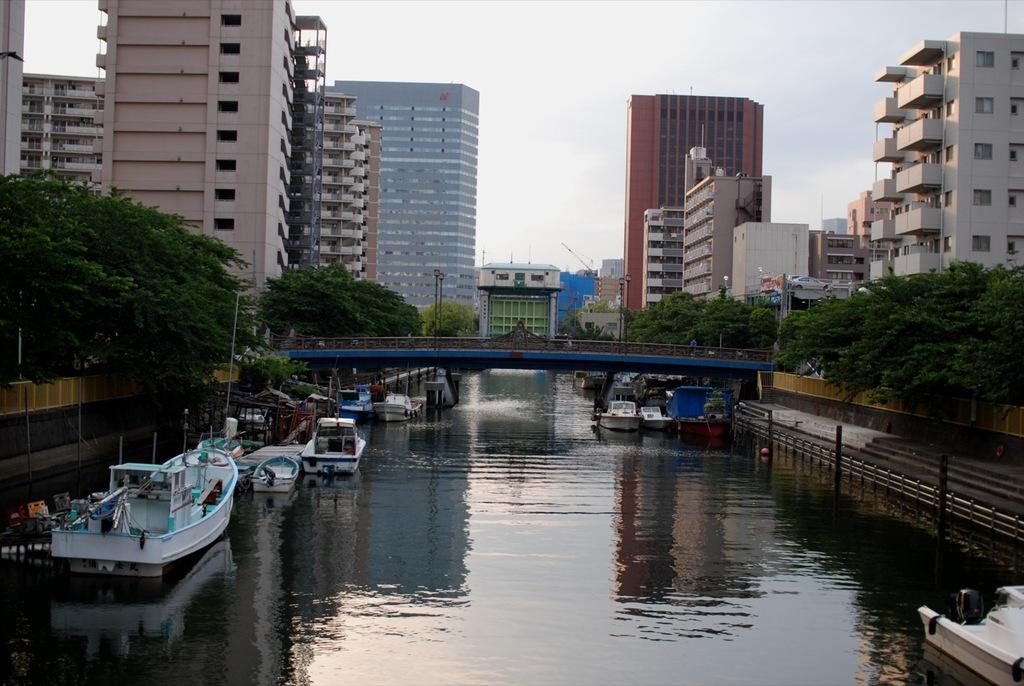What can be seen in the sky in the image? The sky is visible in the image, and clouds are present. What type of structures can be seen in the image? There are buildings and a bridge in the image. What type of barriers are present in the image? Fences are present in the image. What type of vertical structures can be seen in the image? Poles are visible in the image. What type of natural environment is present in the image? Trees are present in the image. What type of water feature is present in the image? There is water in the image, and boats are on the water. Are there any other objects or features in the image? Yes, there are other objects in the image. What time of day is it in the image, and is anyone swimming in the water? The time of day cannot be determined from the image, and there is no indication of anyone swimming in the water. 